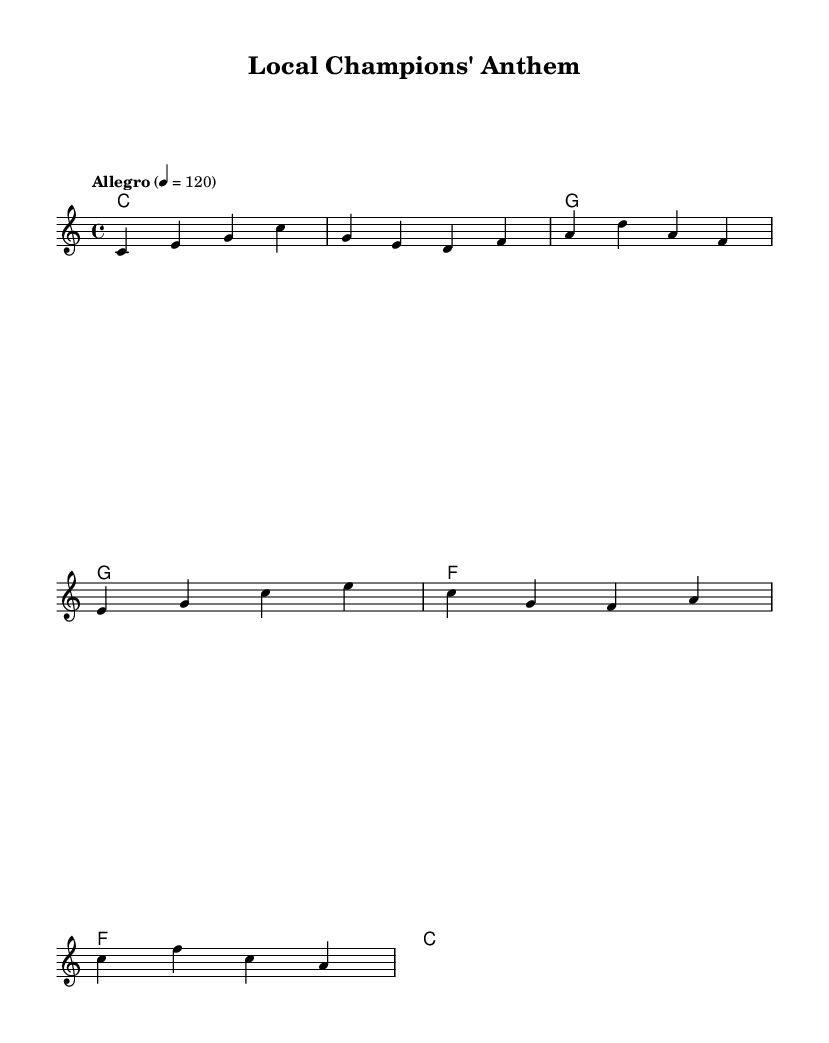What is the key signature of this music? The key signature is shown at the beginning of the staff and indicates the notes that will be sharp or flat throughout the piece. In this case, there are no sharps or flats indicated, meaning the key is C major.
Answer: C major What is the time signature of this music? The time signature is located at the beginning of the piece and indicates how many beats are in each measure. Here, it shows 4/4, meaning there are four beats in each measure and a quarter note gets one beat.
Answer: 4/4 What is the tempo marking of this music? The tempo marking is displayed above the staff and instructs performers on how fast to play the piece. In this sheet music, it is marked as "Allegro" with a metronome marking of 120, indicating a quick tempo.
Answer: Allegro 120 How many measures are in the score? To find the number of measures, count the groupings of notes separated by vertical lines (bar lines). In this case, there are 8 measures, each defined by a bar line.
Answer: 8 What is the harmony for the first measure? The harmonies below the melody show the chords being played. In the first measure, the harmony is C major, as indicated by the chord name in the chord mode.
Answer: C What is the last note in the melody? To determine the last note in the melody line, identify the final note played right before the end of the staff. Here, the last note is an F.
Answer: F What festive theme does this piece celebrate? The context of the music, titled "Local Champions' Anthem," implies it is an uplifting piece celebrating sports heroes, as indicated by the title and orchestral style.
Answer: Local sports heroes 